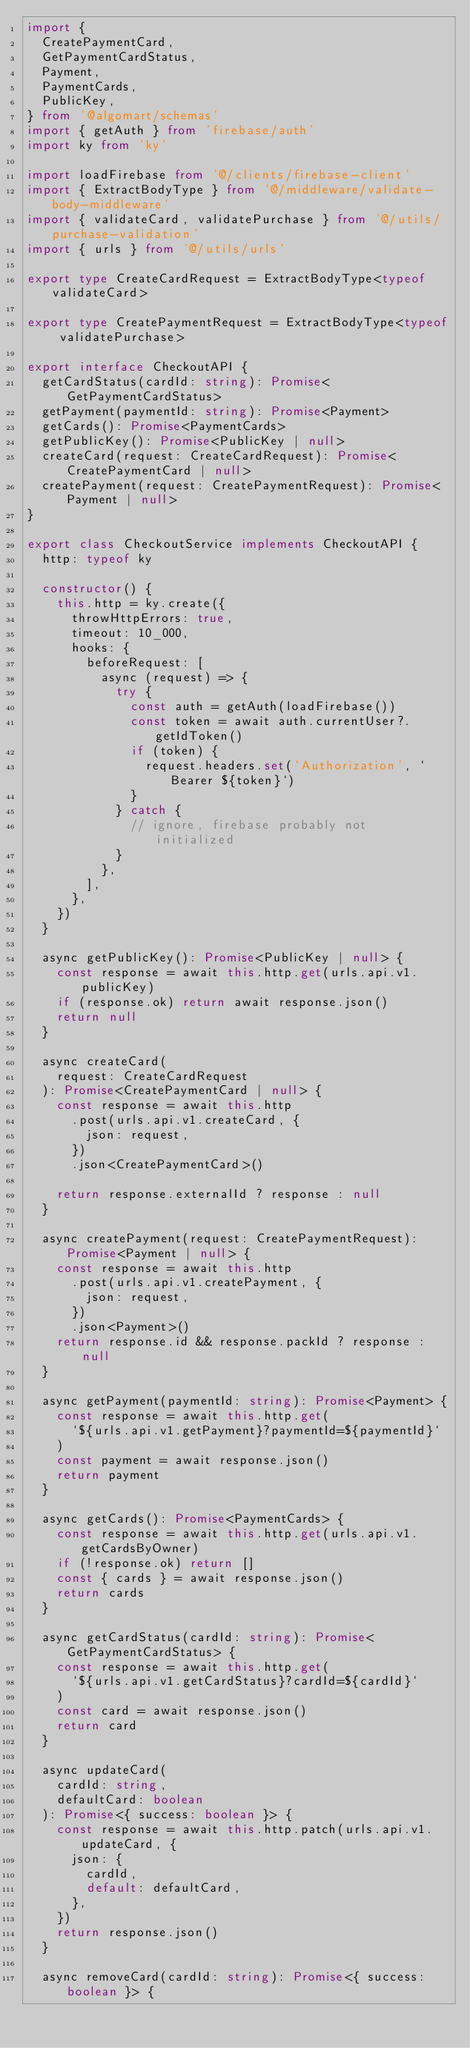Convert code to text. <code><loc_0><loc_0><loc_500><loc_500><_TypeScript_>import {
  CreatePaymentCard,
  GetPaymentCardStatus,
  Payment,
  PaymentCards,
  PublicKey,
} from '@algomart/schemas'
import { getAuth } from 'firebase/auth'
import ky from 'ky'

import loadFirebase from '@/clients/firebase-client'
import { ExtractBodyType } from '@/middleware/validate-body-middleware'
import { validateCard, validatePurchase } from '@/utils/purchase-validation'
import { urls } from '@/utils/urls'

export type CreateCardRequest = ExtractBodyType<typeof validateCard>

export type CreatePaymentRequest = ExtractBodyType<typeof validatePurchase>

export interface CheckoutAPI {
  getCardStatus(cardId: string): Promise<GetPaymentCardStatus>
  getPayment(paymentId: string): Promise<Payment>
  getCards(): Promise<PaymentCards>
  getPublicKey(): Promise<PublicKey | null>
  createCard(request: CreateCardRequest): Promise<CreatePaymentCard | null>
  createPayment(request: CreatePaymentRequest): Promise<Payment | null>
}

export class CheckoutService implements CheckoutAPI {
  http: typeof ky

  constructor() {
    this.http = ky.create({
      throwHttpErrors: true,
      timeout: 10_000,
      hooks: {
        beforeRequest: [
          async (request) => {
            try {
              const auth = getAuth(loadFirebase())
              const token = await auth.currentUser?.getIdToken()
              if (token) {
                request.headers.set('Authorization', `Bearer ${token}`)
              }
            } catch {
              // ignore, firebase probably not initialized
            }
          },
        ],
      },
    })
  }

  async getPublicKey(): Promise<PublicKey | null> {
    const response = await this.http.get(urls.api.v1.publicKey)
    if (response.ok) return await response.json()
    return null
  }

  async createCard(
    request: CreateCardRequest
  ): Promise<CreatePaymentCard | null> {
    const response = await this.http
      .post(urls.api.v1.createCard, {
        json: request,
      })
      .json<CreatePaymentCard>()

    return response.externalId ? response : null
  }

  async createPayment(request: CreatePaymentRequest): Promise<Payment | null> {
    const response = await this.http
      .post(urls.api.v1.createPayment, {
        json: request,
      })
      .json<Payment>()
    return response.id && response.packId ? response : null
  }

  async getPayment(paymentId: string): Promise<Payment> {
    const response = await this.http.get(
      `${urls.api.v1.getPayment}?paymentId=${paymentId}`
    )
    const payment = await response.json()
    return payment
  }

  async getCards(): Promise<PaymentCards> {
    const response = await this.http.get(urls.api.v1.getCardsByOwner)
    if (!response.ok) return []
    const { cards } = await response.json()
    return cards
  }

  async getCardStatus(cardId: string): Promise<GetPaymentCardStatus> {
    const response = await this.http.get(
      `${urls.api.v1.getCardStatus}?cardId=${cardId}`
    )
    const card = await response.json()
    return card
  }

  async updateCard(
    cardId: string,
    defaultCard: boolean
  ): Promise<{ success: boolean }> {
    const response = await this.http.patch(urls.api.v1.updateCard, {
      json: {
        cardId,
        default: defaultCard,
      },
    })
    return response.json()
  }

  async removeCard(cardId: string): Promise<{ success: boolean }> {</code> 